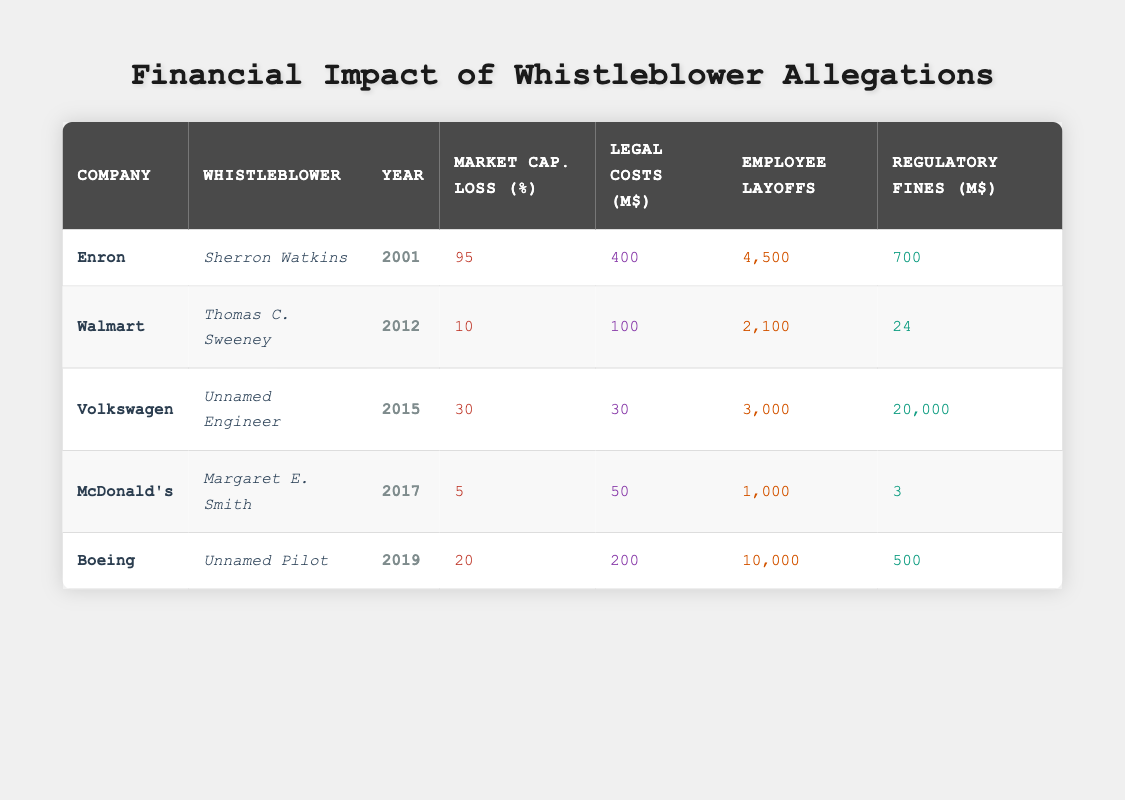What was the market capitalization loss for Enron? The table shows that for Enron, the market capitalization loss was 95%.
Answer: 95% How many employees were laid off at Walmart? According to the table, Walmart had 2,100 employee layoffs.
Answer: 2,100 Which company incurred the highest legal costs? The data indicates that Enron incurred the highest legal costs of 400 million dollars.
Answer: Enron What is the average market capitalization loss for all companies listed? To find the average, sum all the market capitalization losses: (95 + 10 + 30 + 5 + 20) = 160. There are 5 companies, so the average is 160/5 = 32.
Answer: 32 Did Volkswagen have a lower market capitalization loss than Boeing? Volkswagen had a market capitalization loss of 30%, while Boeing's loss was 20%, indicating Boeing had a lower loss.
Answer: Yes What is the total legal cost incurred by the companies in the table? The total is calculated as follows: 400 (Enron) + 100 (Walmart) + 30 (Volkswagen) + 50 (McDonald's) + 200 (Boeing) = 880 million dollars.
Answer: 880 How many employee layoffs occurred across all companies? The total employee layoffs are: 4500 (Enron) + 2100 (Walmart) + 3000 (Volkswagen) + 1000 (McDonald's) + 10000 (Boeing) = 20,600 layoffs.
Answer: 20,600 Is the regulatory fine for Volkswagen higher than the combined fines of McDonald's and Boeing? Volkswagen's fine is 20,000 million dollars, while the combined fines for McDonald's (3 million) and Boeing (500 million) total 503 million dollars, so Volkswagen's fine is indeed higher.
Answer: Yes What percentage of market capitalization loss is associated with the highest number of layoffs? Boeing had the highest number of layoffs (10,000) but a market capitalization loss of 20%. While Volkswagen had a lower number of layoffs (3,000) at a higher market capitalization loss of 30%. No correlation can be established with direct comparison.
Answer: N/A 